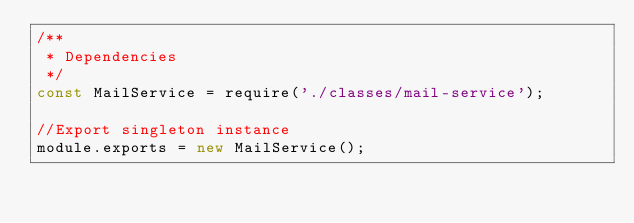Convert code to text. <code><loc_0><loc_0><loc_500><loc_500><_JavaScript_>/**
 * Dependencies
 */
const MailService = require('./classes/mail-service');

//Export singleton instance
module.exports = new MailService();
</code> 